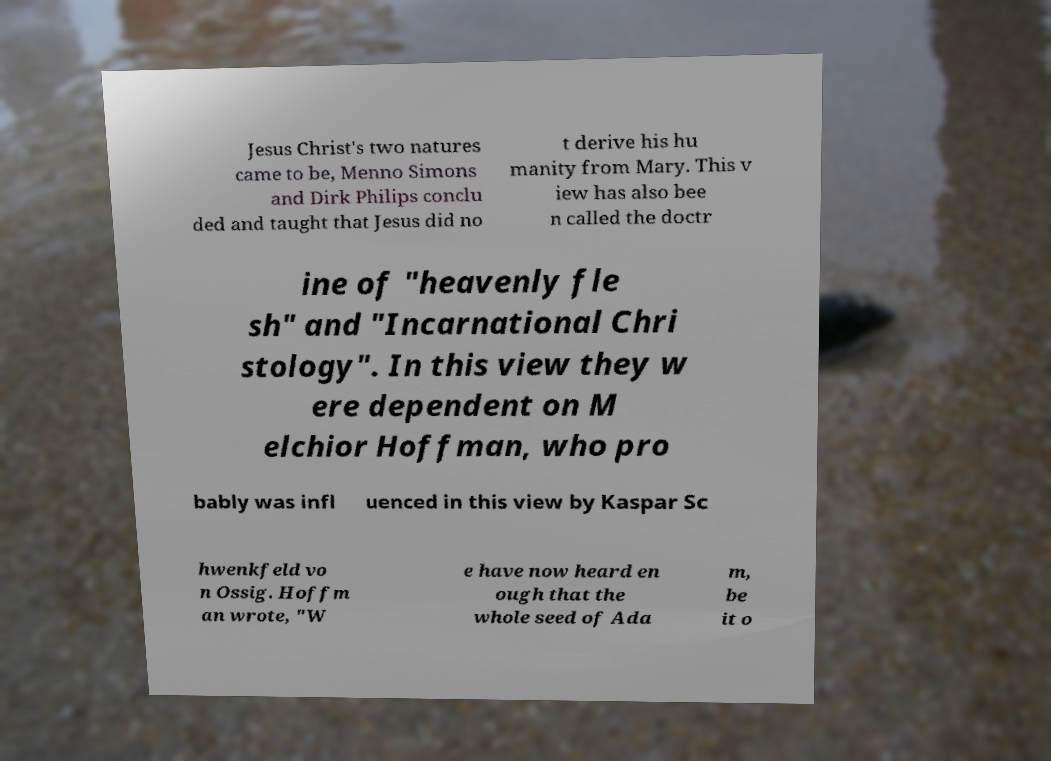Please read and relay the text visible in this image. What does it say? Jesus Christ's two natures came to be, Menno Simons and Dirk Philips conclu ded and taught that Jesus did no t derive his hu manity from Mary. This v iew has also bee n called the doctr ine of "heavenly fle sh" and "Incarnational Chri stology". In this view they w ere dependent on M elchior Hoffman, who pro bably was infl uenced in this view by Kaspar Sc hwenkfeld vo n Ossig. Hoffm an wrote, "W e have now heard en ough that the whole seed of Ada m, be it o 